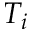Convert formula to latex. <formula><loc_0><loc_0><loc_500><loc_500>T _ { i }</formula> 